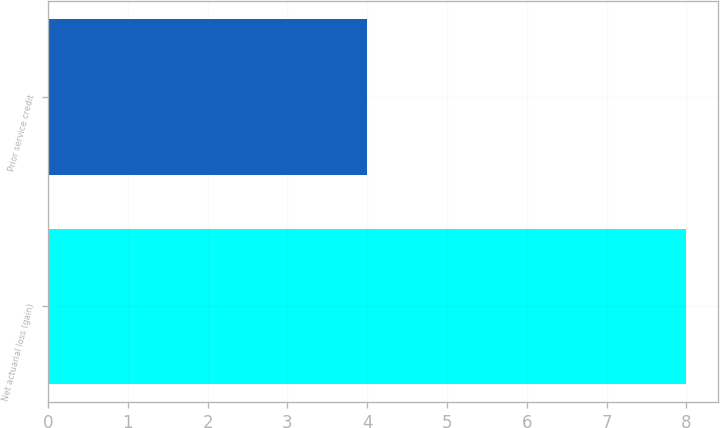<chart> <loc_0><loc_0><loc_500><loc_500><bar_chart><fcel>Net actuarial loss (gain)<fcel>Prior service credit<nl><fcel>8<fcel>4<nl></chart> 